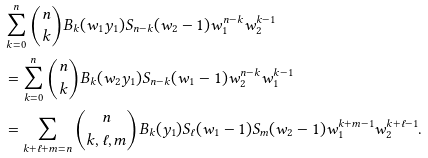<formula> <loc_0><loc_0><loc_500><loc_500>& \sum _ { k = 0 } ^ { n } \binom { n } { k } B _ { k } ( w _ { 1 } y _ { 1 } ) S _ { n - k } ( w _ { 2 } - 1 ) w _ { 1 } ^ { n - k } w _ { 2 } ^ { k - 1 } \\ & = \sum _ { k = 0 } ^ { n } \binom { n } { k } B _ { k } ( w _ { 2 } y _ { 1 } ) S _ { n - k } ( w _ { 1 } - 1 ) w _ { 2 } ^ { n - k } w _ { 1 } ^ { k - 1 } \\ & = \sum _ { k + \ell + m = n } \binom { n } { k , \ell , m } B _ { k } ( y _ { 1 } ) S _ { \ell } ( w _ { 1 } - 1 ) S _ { m } ( w _ { 2 } - 1 ) w _ { 1 } ^ { k + m - 1 } w _ { 2 } ^ { k + \ell - 1 } . \\</formula> 